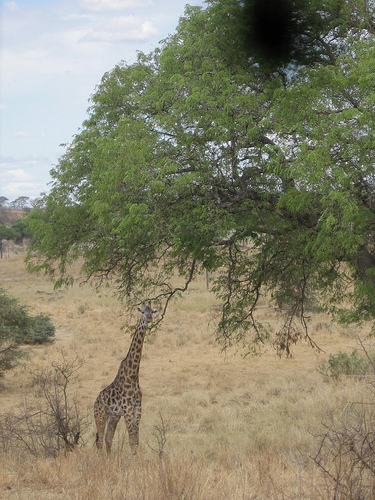<image>Is there a body of water nearby? I don't know if there is a body of water nearby. The majority indicates there isn't one. Is there a body of water nearby? No, there is no body of water nearby. 